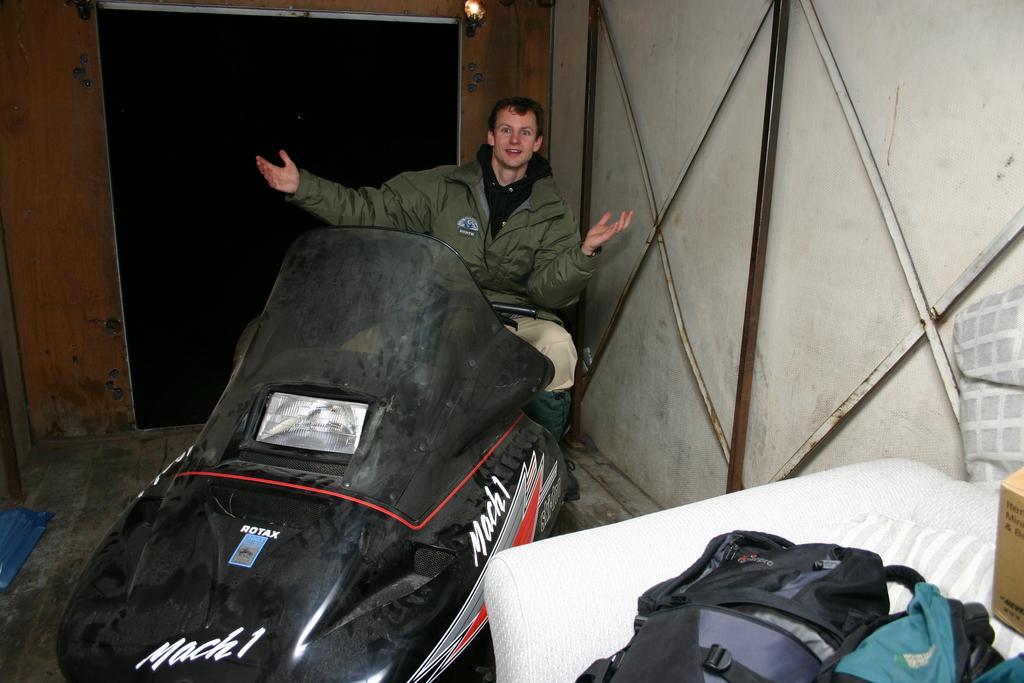How would you summarize this image in a sentence or two? In this image we can see a vehicle on the floor and a person sitting on the seat of it. In the background there are electric lights, walls and bags. 